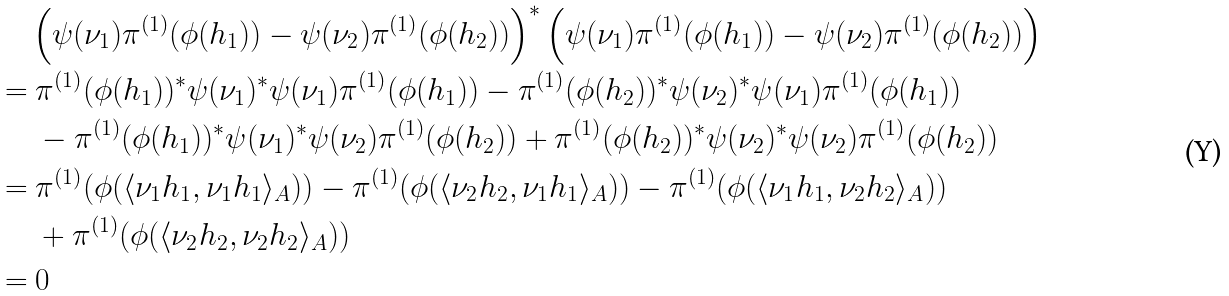<formula> <loc_0><loc_0><loc_500><loc_500>& \left ( \psi ( \nu _ { 1 } ) \pi ^ { ( 1 ) } ( \phi ( h _ { 1 } ) ) - \psi ( \nu _ { 2 } ) \pi ^ { ( 1 ) } ( \phi ( h _ { 2 } ) ) \right ) ^ { * } \left ( \psi ( \nu _ { 1 } ) \pi ^ { ( 1 ) } ( \phi ( h _ { 1 } ) ) - \psi ( \nu _ { 2 } ) \pi ^ { ( 1 ) } ( \phi ( h _ { 2 } ) ) \right ) \\ = & \ \pi ^ { ( 1 ) } ( \phi ( h _ { 1 } ) ) ^ { * } \psi ( \nu _ { 1 } ) ^ { * } \psi ( \nu _ { 1 } ) \pi ^ { ( 1 ) } ( \phi ( h _ { 1 } ) ) - \pi ^ { ( 1 ) } ( \phi ( h _ { 2 } ) ) ^ { * } \psi ( \nu _ { 2 } ) ^ { * } \psi ( \nu _ { 1 } ) \pi ^ { ( 1 ) } ( \phi ( h _ { 1 } ) ) \\ & \ - \pi ^ { ( 1 ) } ( \phi ( h _ { 1 } ) ) ^ { * } \psi ( \nu _ { 1 } ) ^ { * } \psi ( \nu _ { 2 } ) \pi ^ { ( 1 ) } ( \phi ( h _ { 2 } ) ) + \pi ^ { ( 1 ) } ( \phi ( h _ { 2 } ) ) ^ { * } \psi ( \nu _ { 2 } ) ^ { * } \psi ( \nu _ { 2 } ) \pi ^ { ( 1 ) } ( \phi ( h _ { 2 } ) ) \\ = & \ \pi ^ { ( 1 ) } ( \phi ( \langle \nu _ { 1 } h _ { 1 } , \nu _ { 1 } h _ { 1 } \rangle _ { A } ) ) - \pi ^ { ( 1 ) } ( \phi ( \langle \nu _ { 2 } h _ { 2 } , \nu _ { 1 } h _ { 1 } \rangle _ { A } ) ) - \pi ^ { ( 1 ) } ( \phi ( \langle \nu _ { 1 } h _ { 1 } , \nu _ { 2 } h _ { 2 } \rangle _ { A } ) ) \\ & \ + \pi ^ { ( 1 ) } ( \phi ( \langle \nu _ { 2 } h _ { 2 } , \nu _ { 2 } h _ { 2 } \rangle _ { A } ) ) \\ = & \ 0</formula> 